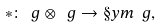Convert formula to latex. <formula><loc_0><loc_0><loc_500><loc_500>* \colon \ g \otimes \ g \rightarrow \S y m \ g ,</formula> 